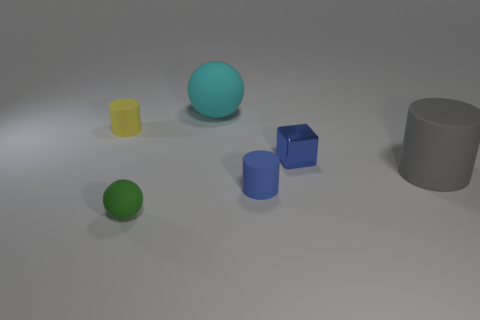Subtract all tiny cylinders. How many cylinders are left? 1 Add 2 blue cylinders. How many objects exist? 8 Subtract 1 cubes. How many cubes are left? 0 Subtract all blue cylinders. How many cylinders are left? 2 Subtract all blocks. How many objects are left? 5 Subtract all yellow cubes. How many purple spheres are left? 0 Subtract all small objects. Subtract all cyan metallic blocks. How many objects are left? 2 Add 3 big matte objects. How many big matte objects are left? 5 Add 2 green balls. How many green balls exist? 3 Subtract 0 gray balls. How many objects are left? 6 